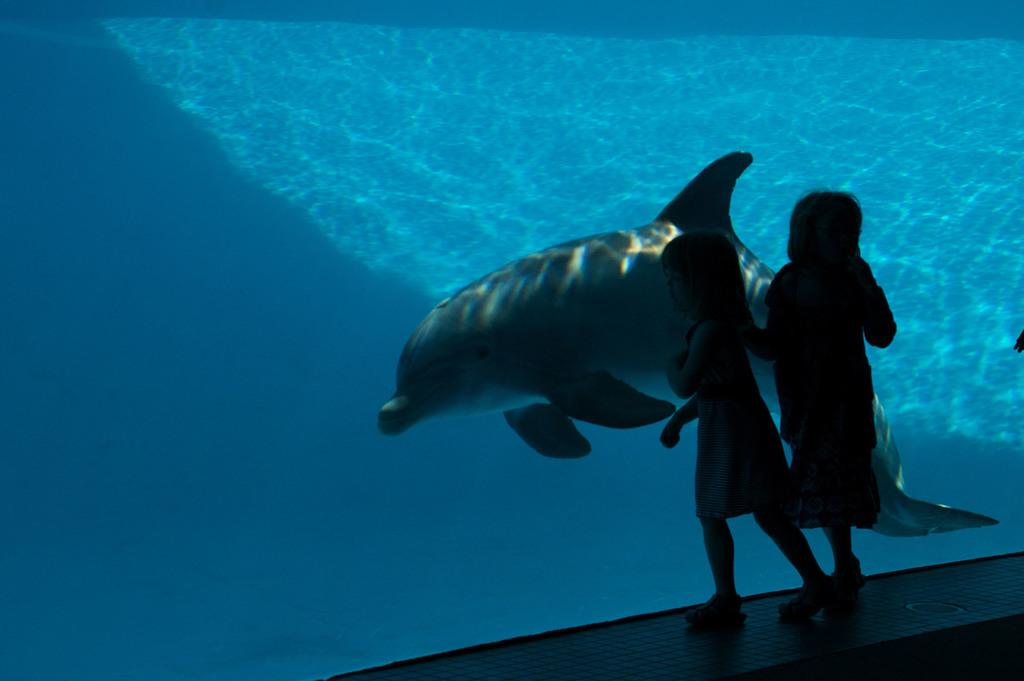How many people are in the image? There are two girls in the image. What are the girls doing in the image? The girls are walking on a platform. What can be seen in the background of the image? There is a dolphin visible in the background of the image. Where is the dolphin located in the image? The dolphin is in the water. What type of brick is being used to build the dress in the image? There is no dress or brick present in the image. What is the wall made of in the image? There is no wall present in the image. 